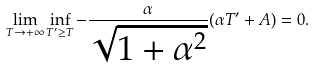Convert formula to latex. <formula><loc_0><loc_0><loc_500><loc_500>\lim _ { T \rightarrow + \infty } \inf _ { T ^ { \prime } \geq T } - \frac { \alpha } { \sqrt { 1 + \alpha ^ { 2 } } } ( \alpha T ^ { \prime } + A ) = 0 .</formula> 